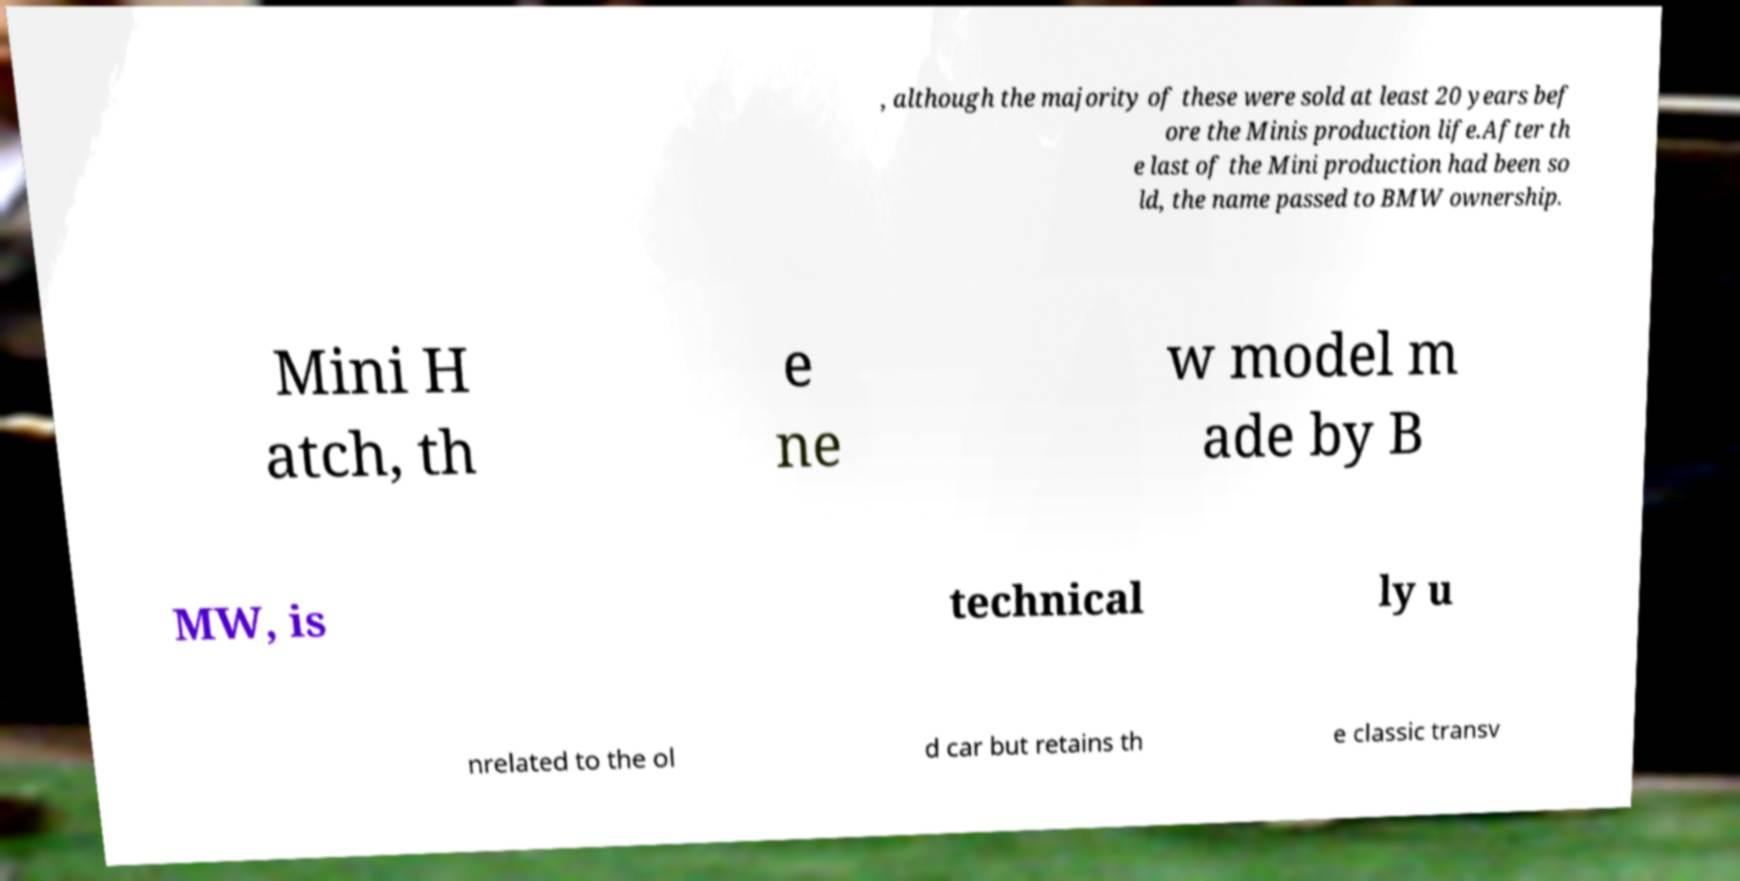What messages or text are displayed in this image? I need them in a readable, typed format. , although the majority of these were sold at least 20 years bef ore the Minis production life.After th e last of the Mini production had been so ld, the name passed to BMW ownership. Mini H atch, th e ne w model m ade by B MW, is technical ly u nrelated to the ol d car but retains th e classic transv 